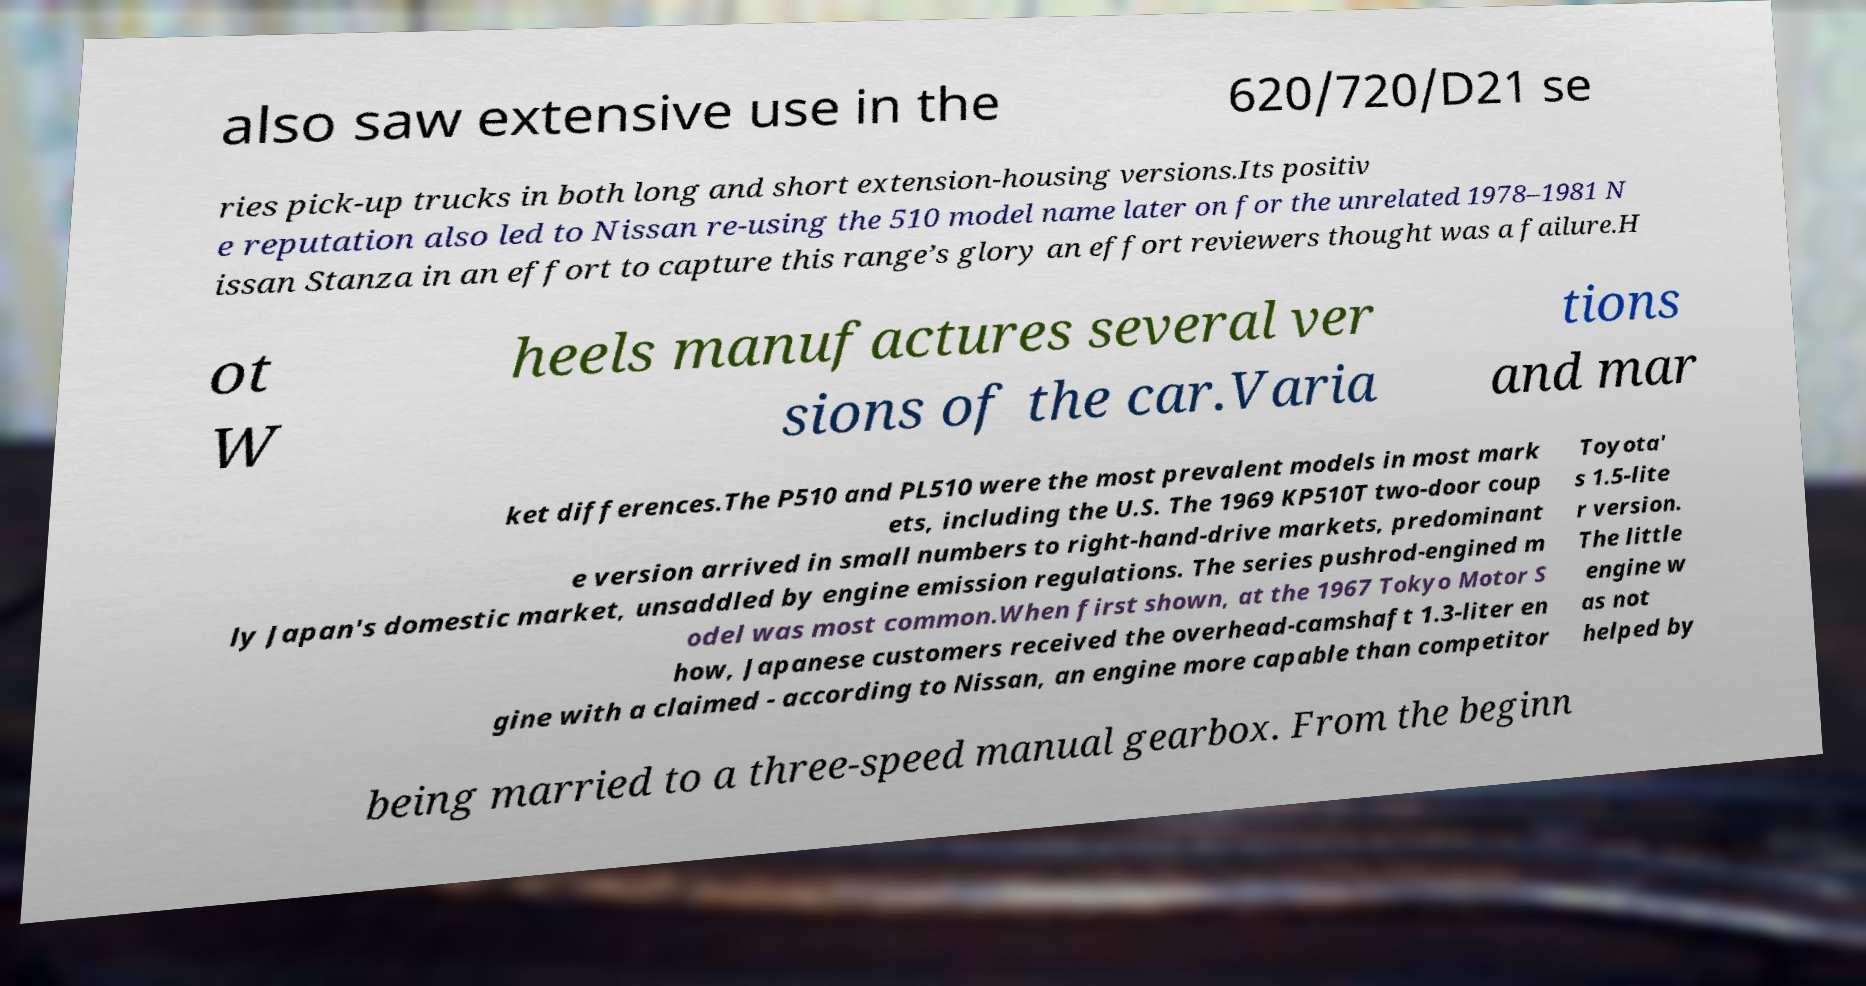Please read and relay the text visible in this image. What does it say? also saw extensive use in the 620/720/D21 se ries pick-up trucks in both long and short extension-housing versions.Its positiv e reputation also led to Nissan re-using the 510 model name later on for the unrelated 1978–1981 N issan Stanza in an effort to capture this range’s glory an effort reviewers thought was a failure.H ot W heels manufactures several ver sions of the car.Varia tions and mar ket differences.The P510 and PL510 were the most prevalent models in most mark ets, including the U.S. The 1969 KP510T two-door coup e version arrived in small numbers to right-hand-drive markets, predominant ly Japan's domestic market, unsaddled by engine emission regulations. The series pushrod-engined m odel was most common.When first shown, at the 1967 Tokyo Motor S how, Japanese customers received the overhead-camshaft 1.3-liter en gine with a claimed - according to Nissan, an engine more capable than competitor Toyota' s 1.5-lite r version. The little engine w as not helped by being married to a three-speed manual gearbox. From the beginn 